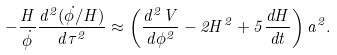<formula> <loc_0><loc_0><loc_500><loc_500>- \frac { H } { \dot { \phi } } \frac { d ^ { 2 } ( { \dot { \phi } } / { H } ) } { d \tau ^ { 2 } } \approx \left ( \frac { d ^ { 2 } V } { d \phi ^ { 2 } } - 2 H ^ { 2 } + 5 \frac { d H } { d t } \right ) a ^ { 2 } .</formula> 